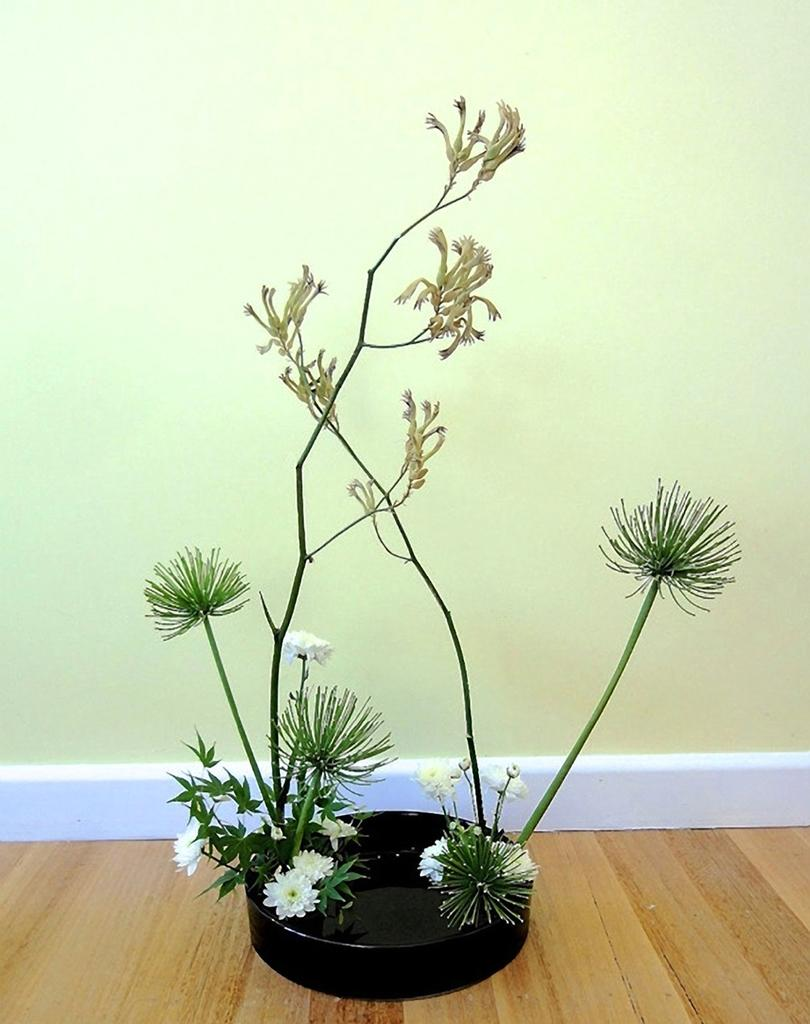What type of plant is visible in the image? There is a decorative plant in the image. What is the plant placed on? The plant is on a black object. What type of flooring is visible in the image? The black object is on the wooden floor. What is behind the plant in the image? There is a wall behind the plant. What kind of trouble is the boy causing in the image? There is no boy present in the image, so it is not possible to determine if there is any trouble or not. 